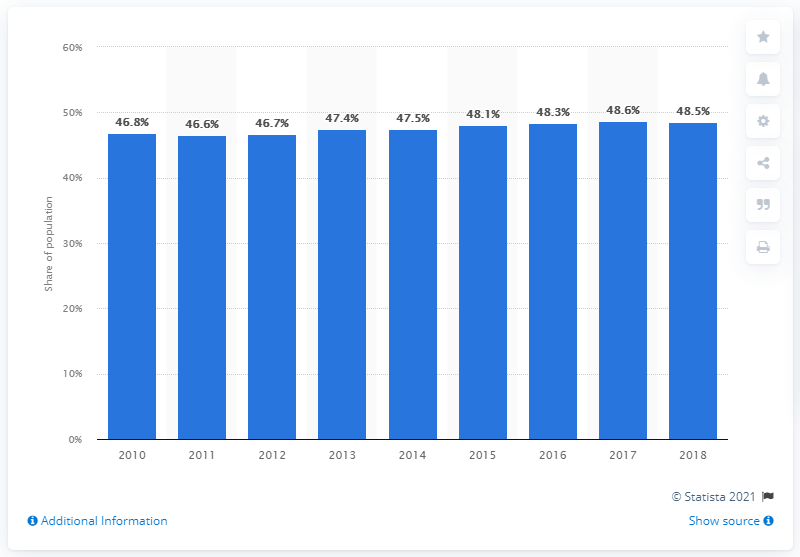Specify some key components in this picture. During the years 2010 to 2018, approximately 48.5% of the population of Germany was composed of tenants. 